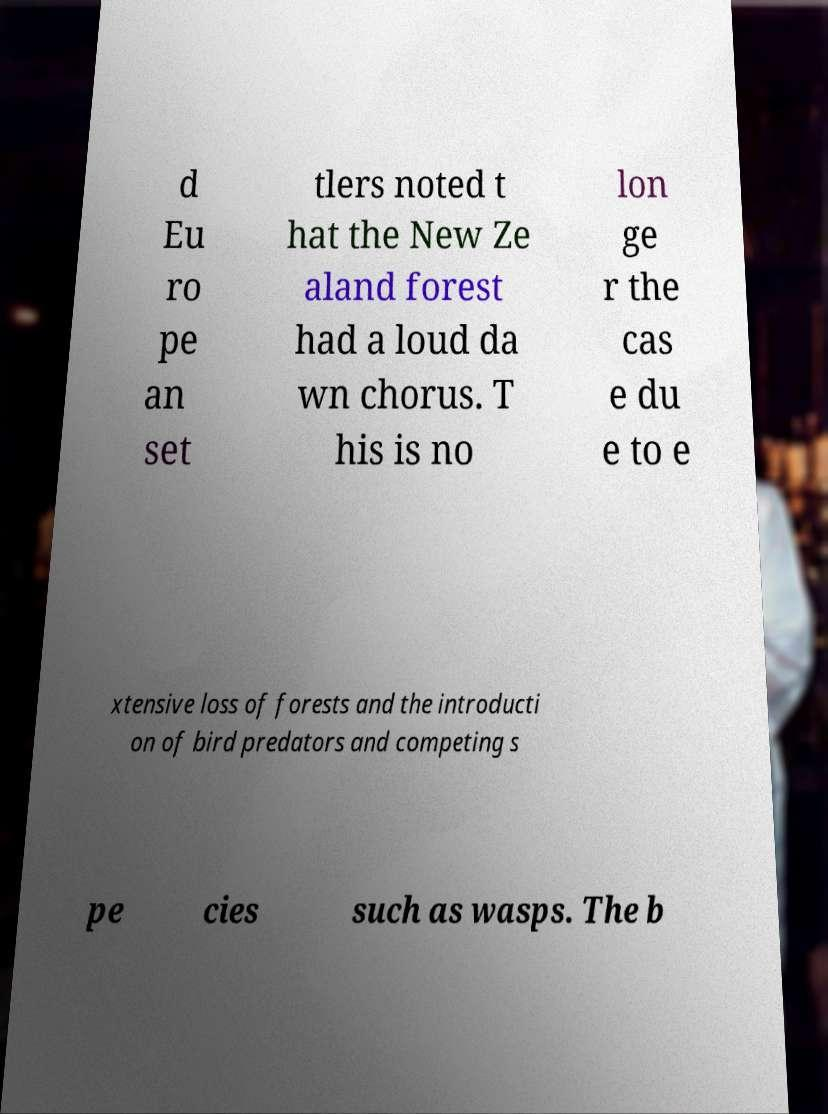Could you assist in decoding the text presented in this image and type it out clearly? d Eu ro pe an set tlers noted t hat the New Ze aland forest had a loud da wn chorus. T his is no lon ge r the cas e du e to e xtensive loss of forests and the introducti on of bird predators and competing s pe cies such as wasps. The b 